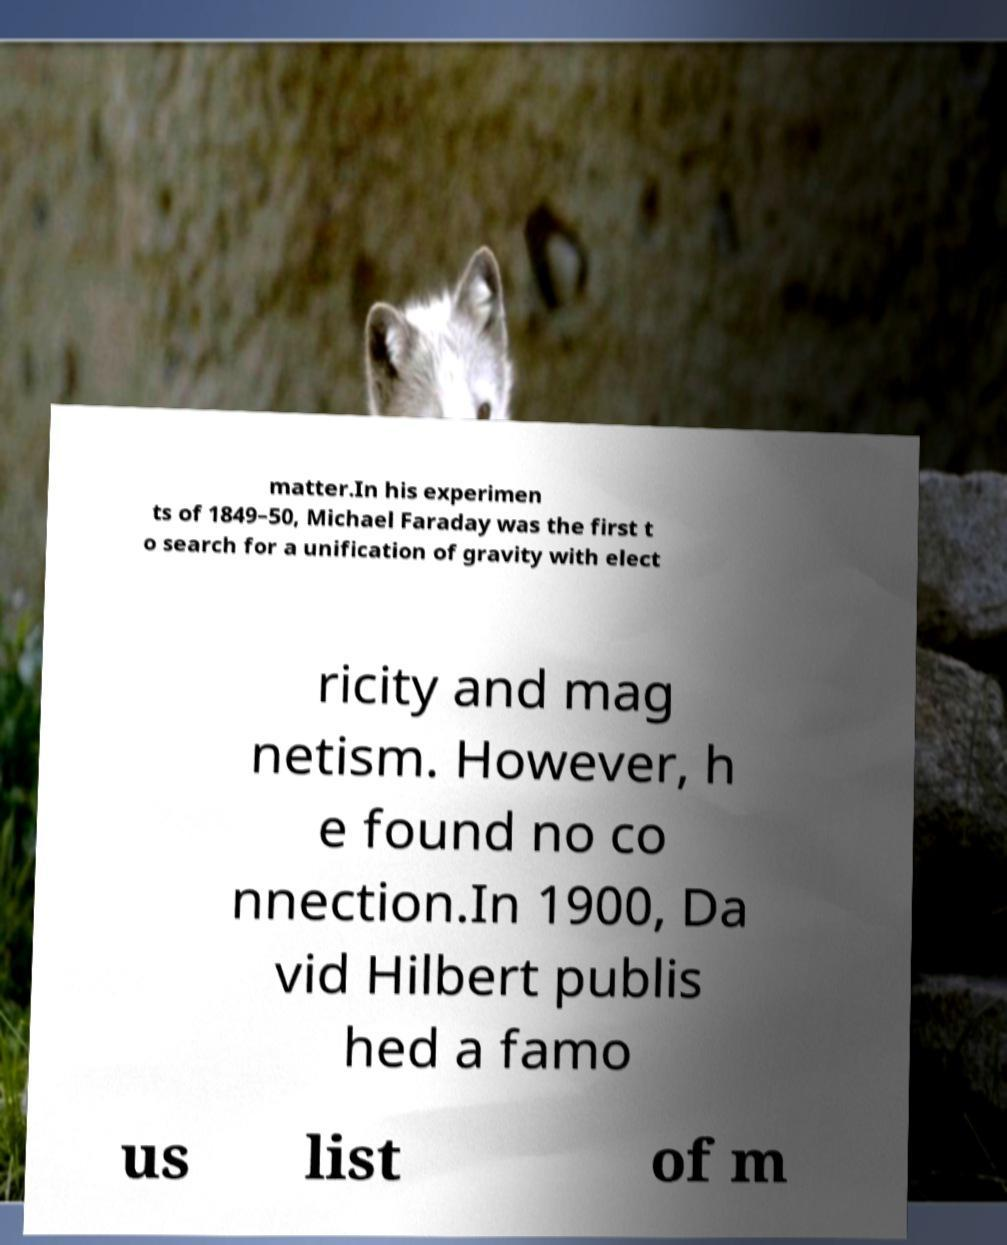There's text embedded in this image that I need extracted. Can you transcribe it verbatim? matter.In his experimen ts of 1849–50, Michael Faraday was the first t o search for a unification of gravity with elect ricity and mag netism. However, h e found no co nnection.In 1900, Da vid Hilbert publis hed a famo us list of m 